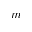<formula> <loc_0><loc_0><loc_500><loc_500>m</formula> 